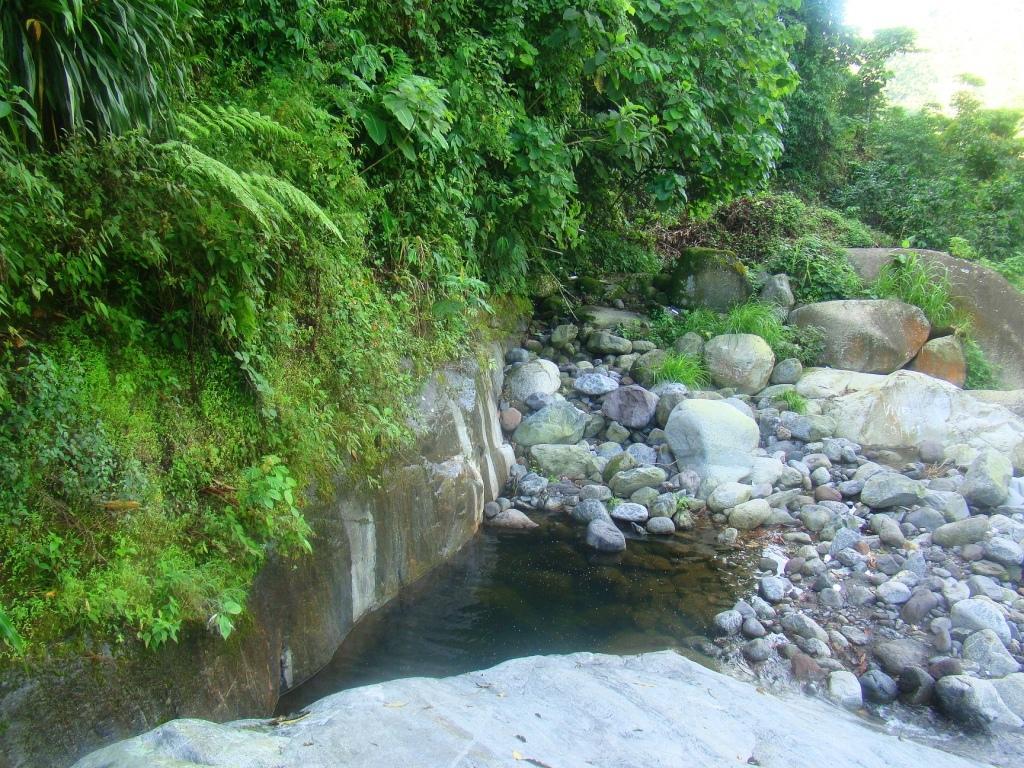Please provide a concise description of this image. In the picture we can see some stones, water and there are some trees. 